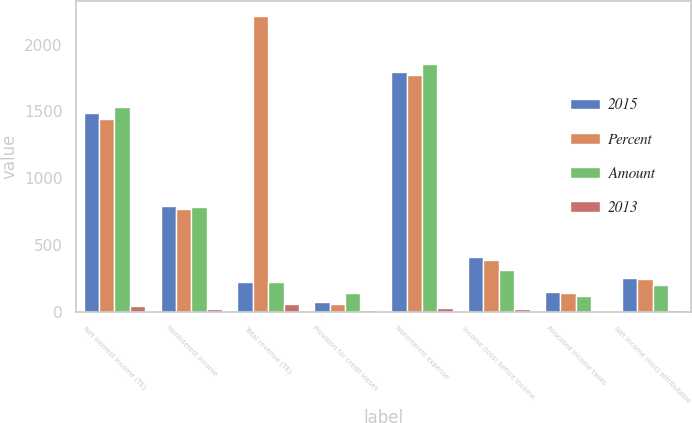Convert chart. <chart><loc_0><loc_0><loc_500><loc_500><stacked_bar_chart><ecel><fcel>Net interest income (TE)<fcel>Noninterest income<fcel>Total revenue (TE)<fcel>Provision for credit losses<fcel>Noninterest expense<fcel>Income (loss) before income<fcel>Allocated income taxes<fcel>Net income (loss) attributable<nl><fcel>2015<fcel>1486<fcel>789<fcel>219.5<fcel>70<fcel>1798<fcel>407<fcel>151<fcel>256<nl><fcel>Percent<fcel>1446<fcel>769<fcel>2215<fcel>59<fcel>1771<fcel>385<fcel>143<fcel>242<nl><fcel>Amount<fcel>1531<fcel>784<fcel>219.5<fcel>143<fcel>1858<fcel>314<fcel>117<fcel>197<nl><fcel>2013<fcel>40<fcel>20<fcel>60<fcel>11<fcel>27<fcel>22<fcel>8<fcel>14<nl></chart> 